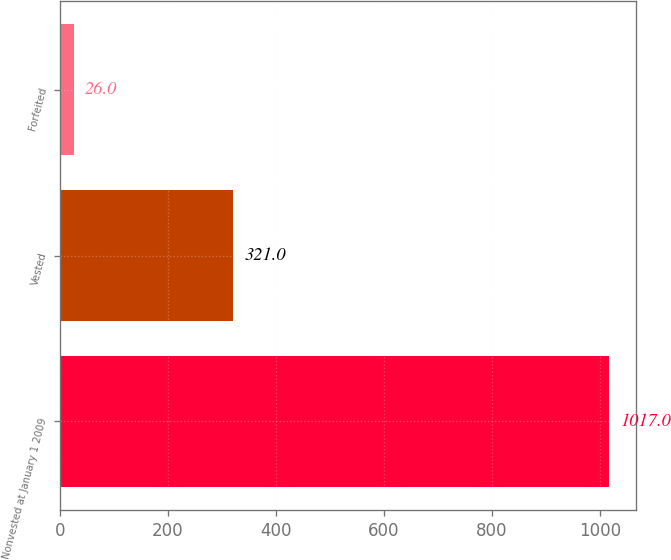Convert chart. <chart><loc_0><loc_0><loc_500><loc_500><bar_chart><fcel>Nonvested at January 1 2009<fcel>Vested<fcel>Forfeited<nl><fcel>1017<fcel>321<fcel>26<nl></chart> 